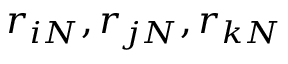<formula> <loc_0><loc_0><loc_500><loc_500>r _ { i N } , r _ { j N } , r _ { k N }</formula> 